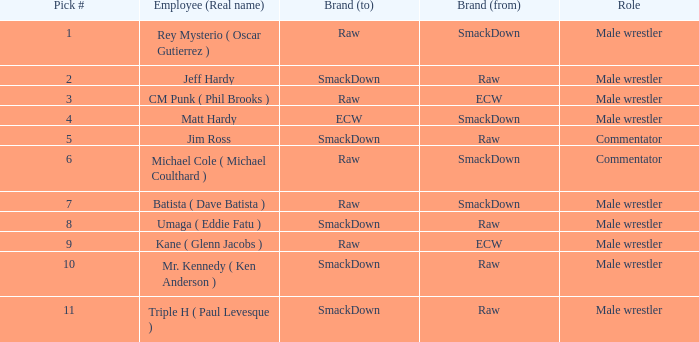What is the real name of the Pick # that is greater than 9? Mr. Kennedy ( Ken Anderson ), Triple H ( Paul Levesque ). 